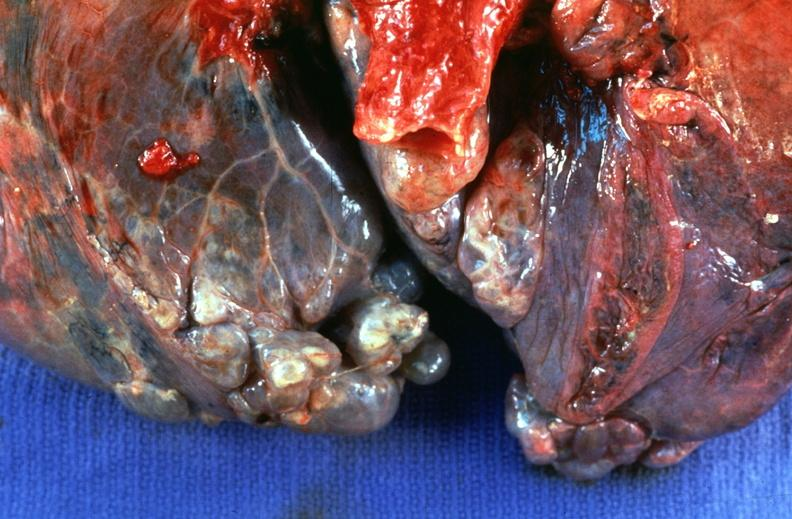does this image show lung, emphysema severe with bullae?
Answer the question using a single word or phrase. Yes 